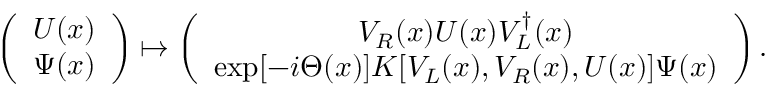Convert formula to latex. <formula><loc_0><loc_0><loc_500><loc_500>\left ( \begin{array} { c } { U ( x ) } \\ { \Psi ( x ) } \end{array} \right ) \mapsto \left ( \begin{array} { c } { { V _ { R } ( x ) U ( x ) V _ { L } ^ { \dagger } ( x ) } } \\ { { \exp [ - i \Theta ( x ) ] K [ V _ { L } ( x ) , V _ { R } ( x ) , U ( x ) ] \Psi ( x ) } } \end{array} \right ) .</formula> 